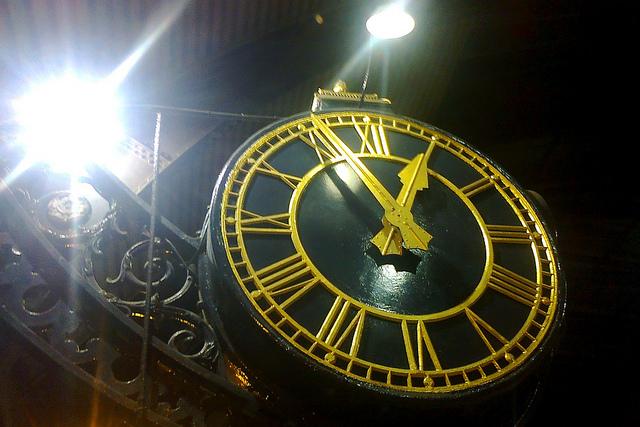Is this clock suspended from the ceiling?
Be succinct. Yes. What color neon is this clock?
Answer briefly. Yellow. Do you think this is a beautiful clock?
Quick response, please. Yes. What time is displayed?
Give a very brief answer. 12:55. 